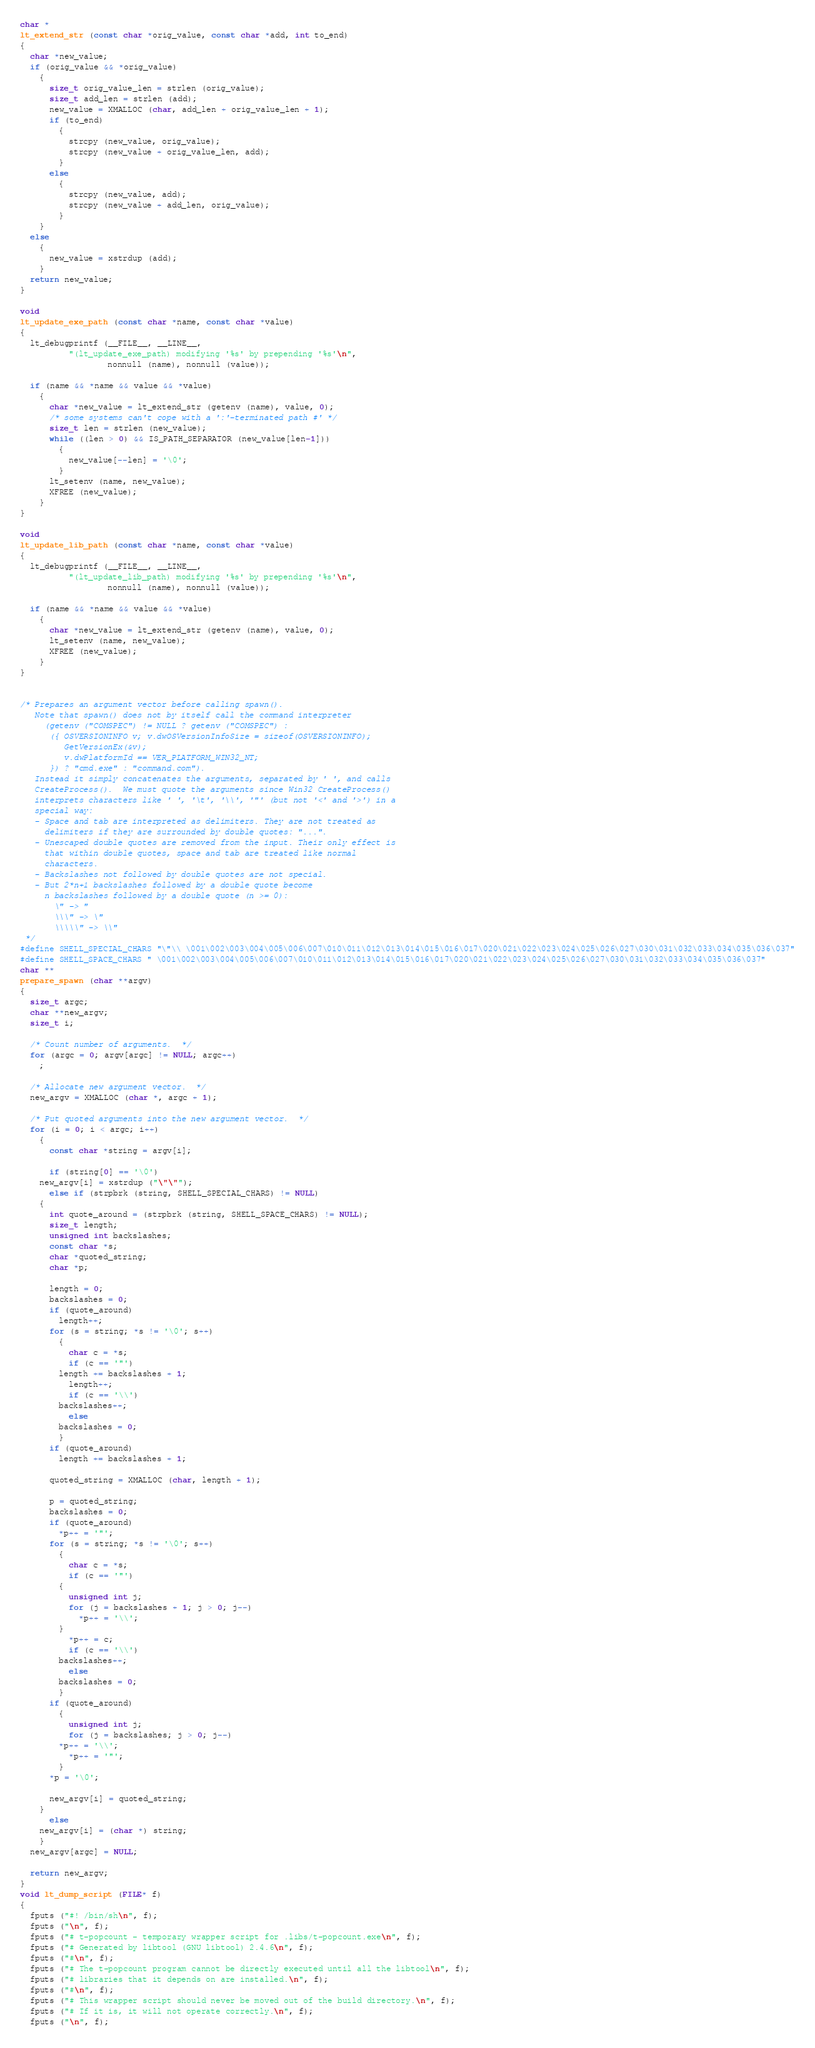Convert code to text. <code><loc_0><loc_0><loc_500><loc_500><_C_>char *
lt_extend_str (const char *orig_value, const char *add, int to_end)
{
  char *new_value;
  if (orig_value && *orig_value)
    {
      size_t orig_value_len = strlen (orig_value);
      size_t add_len = strlen (add);
      new_value = XMALLOC (char, add_len + orig_value_len + 1);
      if (to_end)
        {
          strcpy (new_value, orig_value);
          strcpy (new_value + orig_value_len, add);
        }
      else
        {
          strcpy (new_value, add);
          strcpy (new_value + add_len, orig_value);
        }
    }
  else
    {
      new_value = xstrdup (add);
    }
  return new_value;
}

void
lt_update_exe_path (const char *name, const char *value)
{
  lt_debugprintf (__FILE__, __LINE__,
		  "(lt_update_exe_path) modifying '%s' by prepending '%s'\n",
                  nonnull (name), nonnull (value));

  if (name && *name && value && *value)
    {
      char *new_value = lt_extend_str (getenv (name), value, 0);
      /* some systems can't cope with a ':'-terminated path #' */
      size_t len = strlen (new_value);
      while ((len > 0) && IS_PATH_SEPARATOR (new_value[len-1]))
        {
          new_value[--len] = '\0';
        }
      lt_setenv (name, new_value);
      XFREE (new_value);
    }
}

void
lt_update_lib_path (const char *name, const char *value)
{
  lt_debugprintf (__FILE__, __LINE__,
		  "(lt_update_lib_path) modifying '%s' by prepending '%s'\n",
                  nonnull (name), nonnull (value));

  if (name && *name && value && *value)
    {
      char *new_value = lt_extend_str (getenv (name), value, 0);
      lt_setenv (name, new_value);
      XFREE (new_value);
    }
}


/* Prepares an argument vector before calling spawn().
   Note that spawn() does not by itself call the command interpreter
     (getenv ("COMSPEC") != NULL ? getenv ("COMSPEC") :
      ({ OSVERSIONINFO v; v.dwOSVersionInfoSize = sizeof(OSVERSIONINFO);
         GetVersionEx(&v);
         v.dwPlatformId == VER_PLATFORM_WIN32_NT;
      }) ? "cmd.exe" : "command.com").
   Instead it simply concatenates the arguments, separated by ' ', and calls
   CreateProcess().  We must quote the arguments since Win32 CreateProcess()
   interprets characters like ' ', '\t', '\\', '"' (but not '<' and '>') in a
   special way:
   - Space and tab are interpreted as delimiters. They are not treated as
     delimiters if they are surrounded by double quotes: "...".
   - Unescaped double quotes are removed from the input. Their only effect is
     that within double quotes, space and tab are treated like normal
     characters.
   - Backslashes not followed by double quotes are not special.
   - But 2*n+1 backslashes followed by a double quote become
     n backslashes followed by a double quote (n >= 0):
       \" -> "
       \\\" -> \"
       \\\\\" -> \\"
 */
#define SHELL_SPECIAL_CHARS "\"\\ \001\002\003\004\005\006\007\010\011\012\013\014\015\016\017\020\021\022\023\024\025\026\027\030\031\032\033\034\035\036\037"
#define SHELL_SPACE_CHARS " \001\002\003\004\005\006\007\010\011\012\013\014\015\016\017\020\021\022\023\024\025\026\027\030\031\032\033\034\035\036\037"
char **
prepare_spawn (char **argv)
{
  size_t argc;
  char **new_argv;
  size_t i;

  /* Count number of arguments.  */
  for (argc = 0; argv[argc] != NULL; argc++)
    ;

  /* Allocate new argument vector.  */
  new_argv = XMALLOC (char *, argc + 1);

  /* Put quoted arguments into the new argument vector.  */
  for (i = 0; i < argc; i++)
    {
      const char *string = argv[i];

      if (string[0] == '\0')
	new_argv[i] = xstrdup ("\"\"");
      else if (strpbrk (string, SHELL_SPECIAL_CHARS) != NULL)
	{
	  int quote_around = (strpbrk (string, SHELL_SPACE_CHARS) != NULL);
	  size_t length;
	  unsigned int backslashes;
	  const char *s;
	  char *quoted_string;
	  char *p;

	  length = 0;
	  backslashes = 0;
	  if (quote_around)
	    length++;
	  for (s = string; *s != '\0'; s++)
	    {
	      char c = *s;
	      if (c == '"')
		length += backslashes + 1;
	      length++;
	      if (c == '\\')
		backslashes++;
	      else
		backslashes = 0;
	    }
	  if (quote_around)
	    length += backslashes + 1;

	  quoted_string = XMALLOC (char, length + 1);

	  p = quoted_string;
	  backslashes = 0;
	  if (quote_around)
	    *p++ = '"';
	  for (s = string; *s != '\0'; s++)
	    {
	      char c = *s;
	      if (c == '"')
		{
		  unsigned int j;
		  for (j = backslashes + 1; j > 0; j--)
		    *p++ = '\\';
		}
	      *p++ = c;
	      if (c == '\\')
		backslashes++;
	      else
		backslashes = 0;
	    }
	  if (quote_around)
	    {
	      unsigned int j;
	      for (j = backslashes; j > 0; j--)
		*p++ = '\\';
	      *p++ = '"';
	    }
	  *p = '\0';

	  new_argv[i] = quoted_string;
	}
      else
	new_argv[i] = (char *) string;
    }
  new_argv[argc] = NULL;

  return new_argv;
}
void lt_dump_script (FILE* f)
{
  fputs ("#! /bin/sh\n", f);
  fputs ("\n", f);
  fputs ("# t-popcount - temporary wrapper script for .libs/t-popcount.exe\n", f);
  fputs ("# Generated by libtool (GNU libtool) 2.4.6\n", f);
  fputs ("#\n", f);
  fputs ("# The t-popcount program cannot be directly executed until all the libtool\n", f);
  fputs ("# libraries that it depends on are installed.\n", f);
  fputs ("#\n", f);
  fputs ("# This wrapper script should never be moved out of the build directory.\n", f);
  fputs ("# If it is, it will not operate correctly.\n", f);
  fputs ("\n", f);</code> 